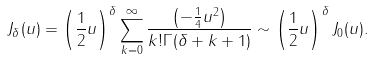Convert formula to latex. <formula><loc_0><loc_0><loc_500><loc_500>J _ { \delta } ( u ) = \left ( \frac { 1 } { 2 } u \right ) ^ { \delta } \sum _ { k = 0 } ^ { \infty } \frac { \left ( - \frac { 1 } { 4 } u ^ { 2 } \right ) } { k ! \Gamma ( \delta + k + 1 ) } \sim \left ( \frac { 1 } { 2 } u \right ) ^ { \delta } J _ { 0 } ( u ) .</formula> 